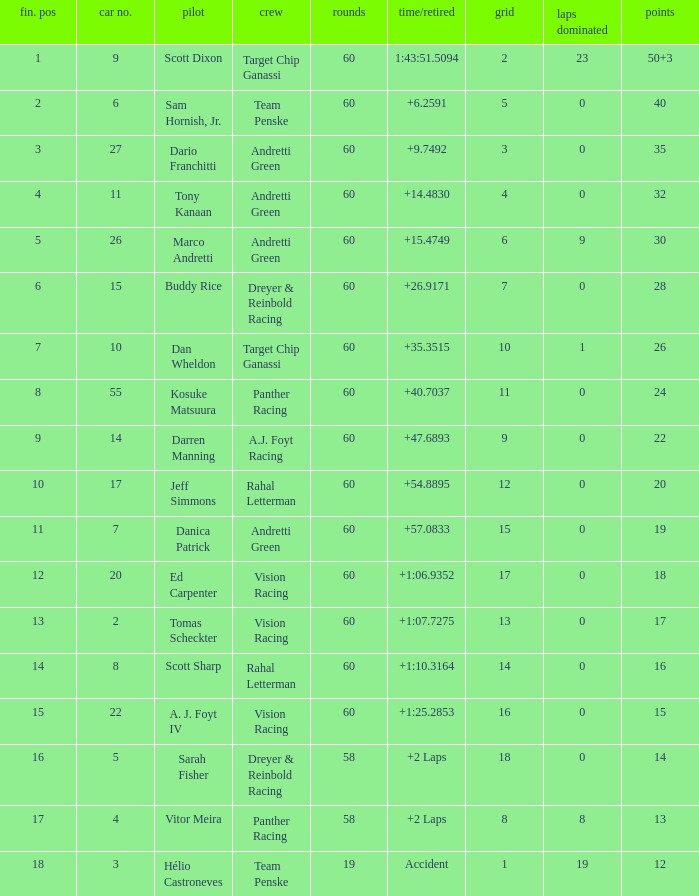Name the team of darren manning A.J. Foyt Racing. 